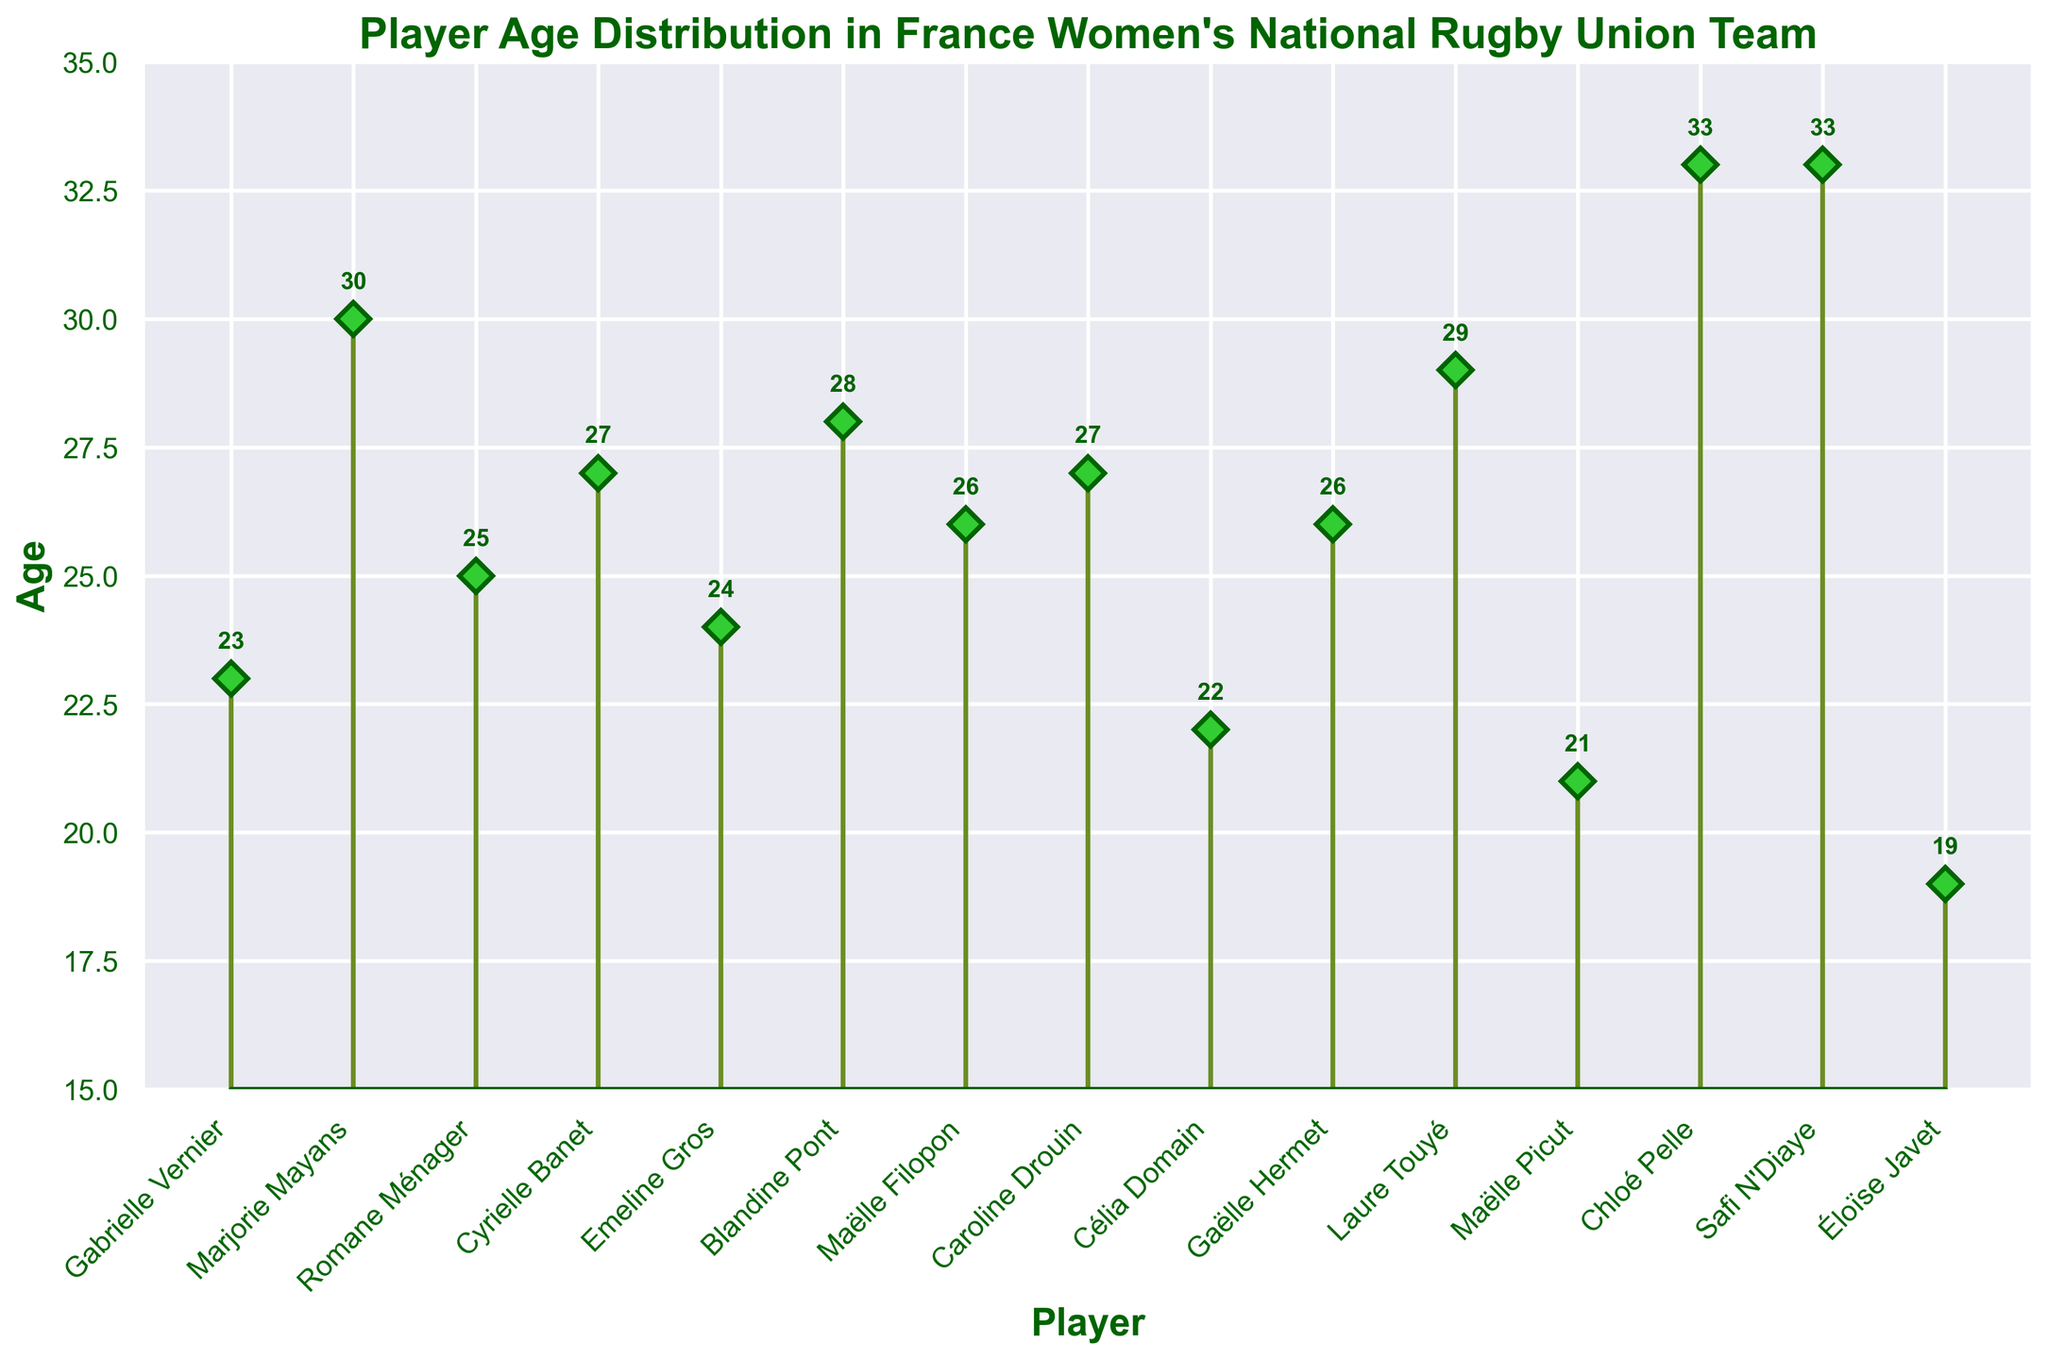What is the title of the plot? The title of the plot is written prominently at the top of the figure.
Answer: "Player Age Distribution in France Women's National Rugby Union Team" What is the age of the youngest player? Look for the lowest data point on the stem plot. In this case, the youngest player's stem is at 19.
Answer: 19 How many players are aged 27 or older? Count all the stems that have a value of 27 or higher. There are six players: Cyrielle Banet (27), Caroline Drouin (27), Blandine Pont (28), Laure Touyé (29), Marjorie Mayans (30), Chloé Pelle (33), and Safi N'Diaye (33).
Answer: 6 Which player is 30 years old? The stem plot indicates the players' ages. Marjorie Mayans is the only player with a stem at 30.
Answer: Marjorie Mayans What is the range of the ages? The range is calculated as the difference between the highest and lowest values on the stem plot. The highest age is 33, and the lowest age is 19. Hence, the range is 33 - 19 = 14.
Answer: 14 What is the average age of the players? Sum all the ages and divide by the number of players. The sum of the ages is 393 and there are 15 players. So, 393 / 15 = 26.2.
Answer: 26.2 How many players are younger than 25? Count all the stems that have a value lower than 25. These players are Éloïse Javet (19), Maëlle Picut (21), Célia Domain (22), and Gabrielle Vernier (23), Emeline Gros (24).
Answer: 5 Who is older, Cyrielle Banet or Caroline Drouin? Compare the stem for both players. Both Cyrielle Banet and Caroline Drouin have stems at 27, meaning their ages are equal.
Answer: Both are the same age Which two players are the oldest on the team? Identify the highest stems; they correspond to Chloé Pelle and Safi N'Diaye, both aged 33.
Answer: Chloé Pelle and Safi N'Diaye What is the median age of the players? Arrange the ages in ascending order: 19, 21, 22, 23, 24, 25, 26, 26, 27, 27, 28, 29, 30, 33, 33. The median is the middle number when arranged in order so the median age is 26.
Answer: 26 